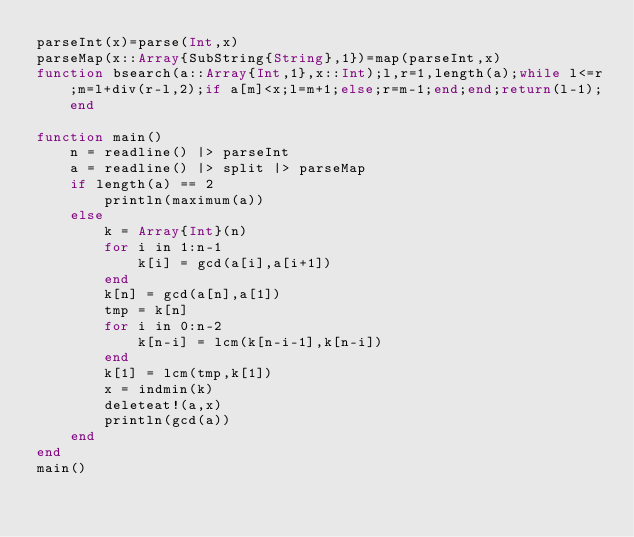Convert code to text. <code><loc_0><loc_0><loc_500><loc_500><_Julia_>parseInt(x)=parse(Int,x)
parseMap(x::Array{SubString{String},1})=map(parseInt,x)
function bsearch(a::Array{Int,1},x::Int);l,r=1,length(a);while l<=r;m=l+div(r-l,2);if a[m]<x;l=m+1;else;r=m-1;end;end;return(l-1);end

function main()
	n = readline() |> parseInt
	a = readline() |> split |> parseMap
	if length(a) == 2
		println(maximum(a))
	else
		k = Array{Int}(n)
		for i in 1:n-1
			k[i] = gcd(a[i],a[i+1])
		end
		k[n] = gcd(a[n],a[1])
	    tmp = k[n]
		for i in 0:n-2
			k[n-i] = lcm(k[n-i-1],k[n-i])
		end
		k[1] = lcm(tmp,k[1])
		x = indmin(k)
		deleteat!(a,x)
		println(gcd(a))	
	end
end
main()
</code> 